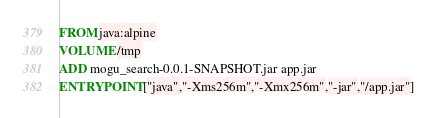<code> <loc_0><loc_0><loc_500><loc_500><_Dockerfile_>FROM java:alpine
VOLUME /tmp
ADD mogu_search-0.0.1-SNAPSHOT.jar app.jar
ENTRYPOINT ["java","-Xms256m","-Xmx256m","-jar","/app.jar"]
</code> 